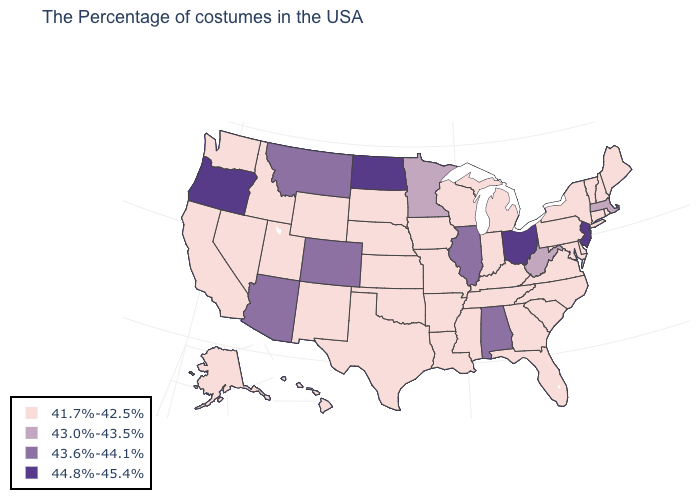Does Connecticut have the highest value in the USA?
Write a very short answer. No. What is the value of Massachusetts?
Short answer required. 43.0%-43.5%. Among the states that border Kentucky , which have the highest value?
Concise answer only. Ohio. Does the first symbol in the legend represent the smallest category?
Write a very short answer. Yes. Which states have the highest value in the USA?
Be succinct. New Jersey, Ohio, North Dakota, Oregon. What is the highest value in the West ?
Keep it brief. 44.8%-45.4%. What is the value of South Carolina?
Give a very brief answer. 41.7%-42.5%. What is the value of Massachusetts?
Concise answer only. 43.0%-43.5%. What is the highest value in the West ?
Quick response, please. 44.8%-45.4%. Among the states that border Rhode Island , does Connecticut have the highest value?
Keep it brief. No. What is the value of Missouri?
Concise answer only. 41.7%-42.5%. Does the first symbol in the legend represent the smallest category?
Concise answer only. Yes. Among the states that border Virginia , does West Virginia have the lowest value?
Concise answer only. No. Does Alabama have the highest value in the South?
Concise answer only. Yes. Name the states that have a value in the range 43.6%-44.1%?
Concise answer only. Alabama, Illinois, Colorado, Montana, Arizona. 